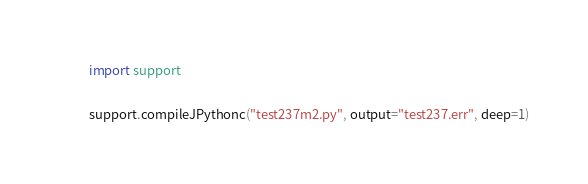Convert code to text. <code><loc_0><loc_0><loc_500><loc_500><_Python_>import support

support.compileJPythonc("test237m2.py", output="test237.err", deep=1)

</code> 